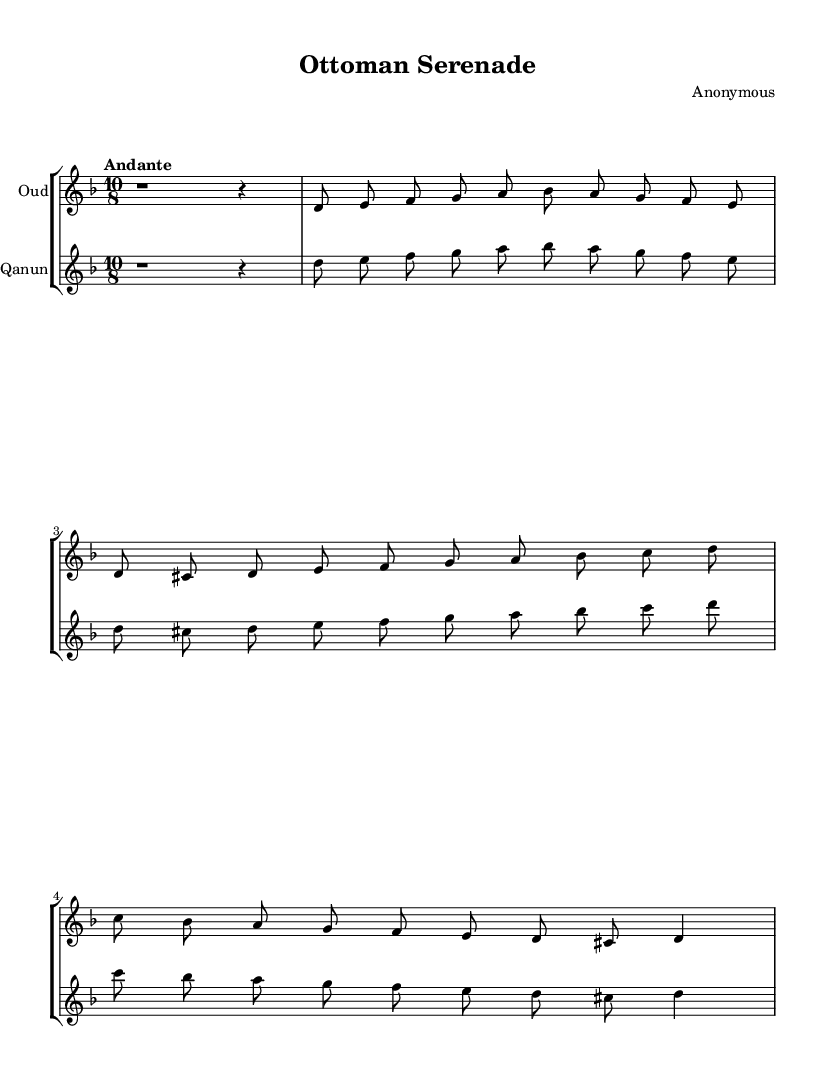What is the key signature of this music? The music is in D minor, as indicated by the key signature that shows one flat (B flat) on the staff.
Answer: D minor What is the time signature of this piece? The time signature is 10/8, which is specified at the beginning of the score. This means there are 10 beats in a measure, and the eighth note gets one beat.
Answer: 10/8 What is the tempo marking for this music? The tempo marking at the beginning of the piece states "Andante," indicating a moderately slow tempo.
Answer: Andante How many measures does the score contain? By counting the measures in the provided music, there are a total of 6 measures. Each line, starting and ending with a brace, contains 2 measures.
Answer: 6 What are the instruments used in this score? The score features two instruments, which are specified at the beginning of each staff as "Oud" and "Qanun."
Answer: Oud, Qanun Is there a repeated melodic figure in the piece? Yes, the melodic phrases for both the oud and qanun are identical, indicating that the same material is played in unison. This is evident when comparing the notes in the corresponding measures.
Answer: Yes 